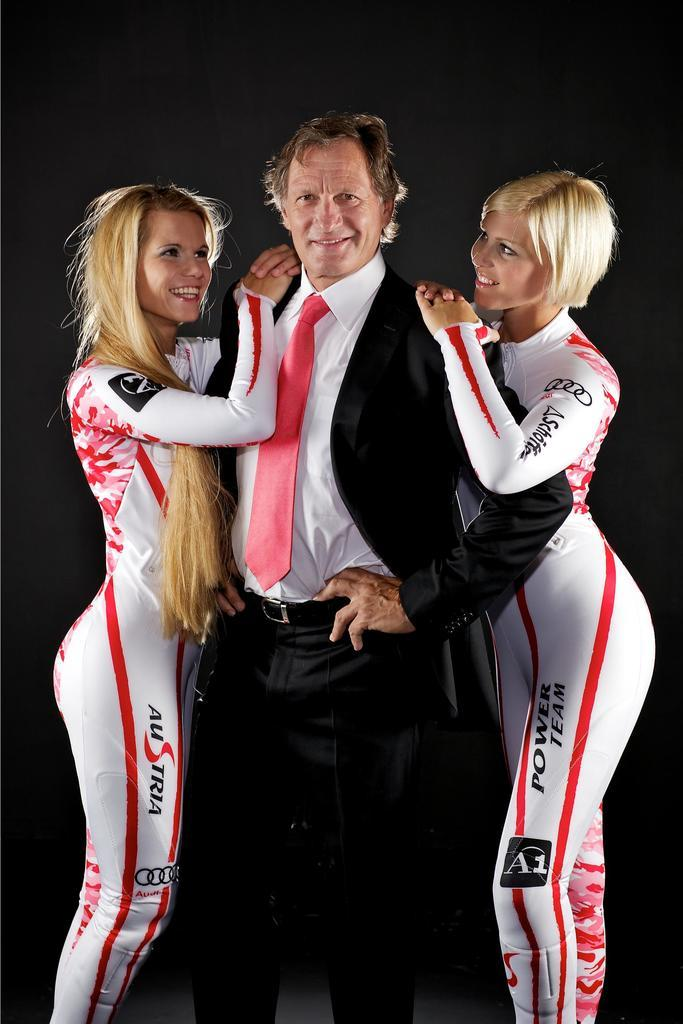Provide a one-sentence caption for the provided image. Two Austrian Power Team women in tight body suits embrace a man in a suit. 